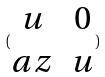Convert formula to latex. <formula><loc_0><loc_0><loc_500><loc_500>( \begin{matrix} u & 0 \\ a z & u \end{matrix} )</formula> 